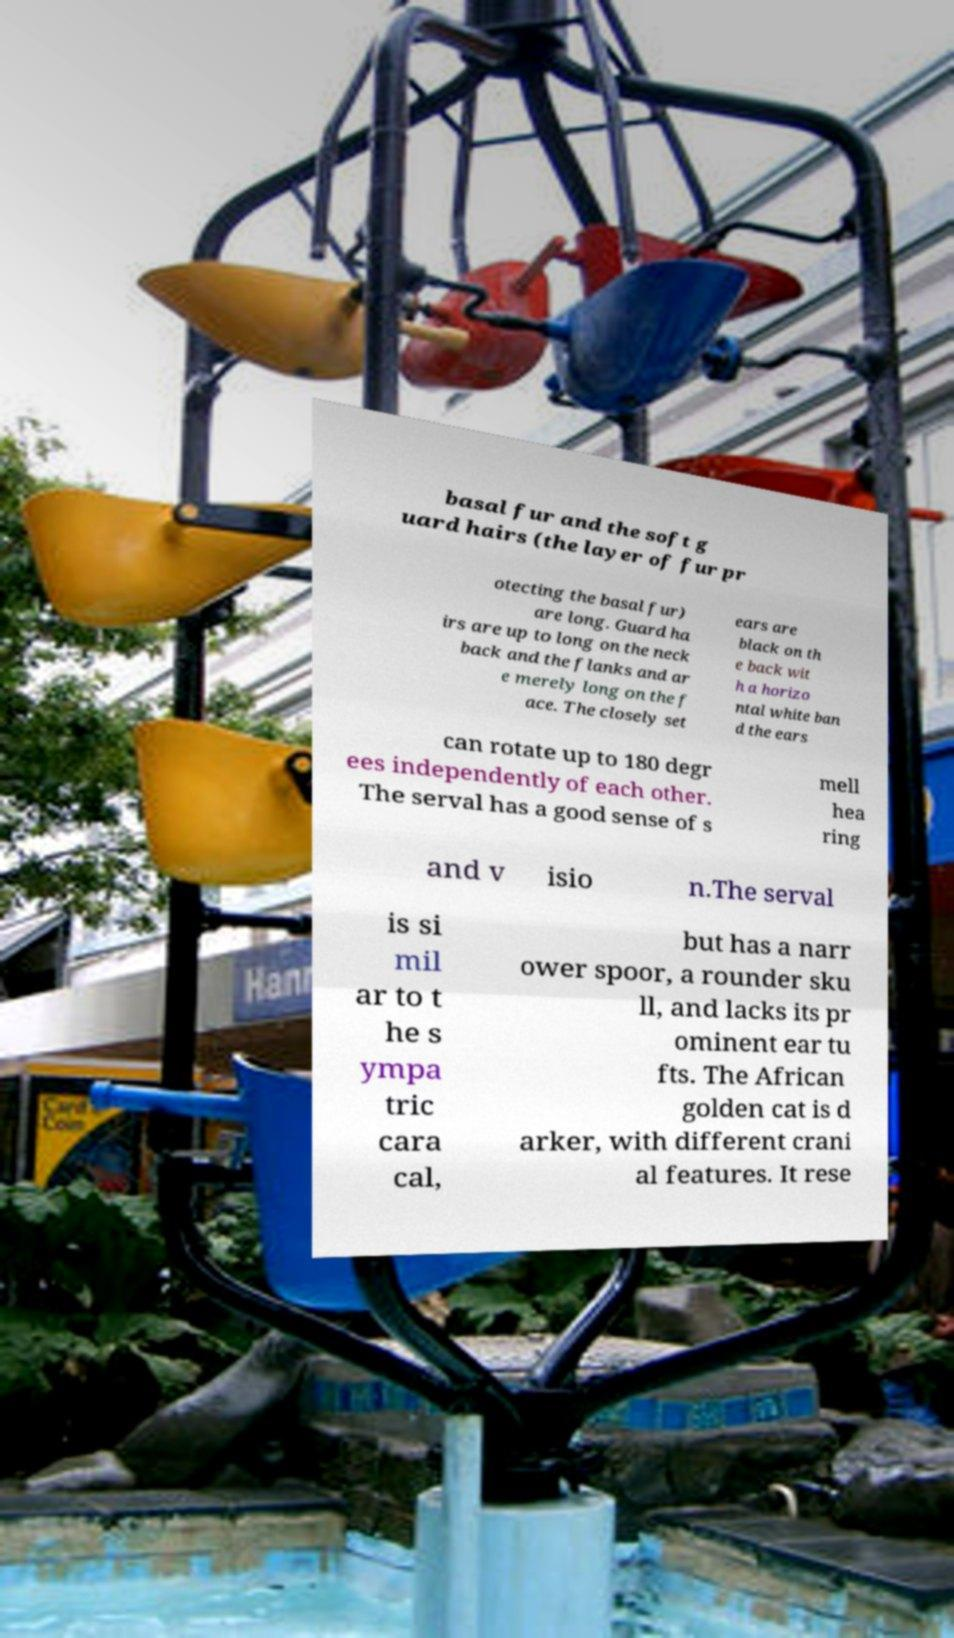Can you accurately transcribe the text from the provided image for me? basal fur and the soft g uard hairs (the layer of fur pr otecting the basal fur) are long. Guard ha irs are up to long on the neck back and the flanks and ar e merely long on the f ace. The closely set ears are black on th e back wit h a horizo ntal white ban d the ears can rotate up to 180 degr ees independently of each other. The serval has a good sense of s mell hea ring and v isio n.The serval is si mil ar to t he s ympa tric cara cal, but has a narr ower spoor, a rounder sku ll, and lacks its pr ominent ear tu fts. The African golden cat is d arker, with different crani al features. It rese 